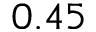<formula> <loc_0><loc_0><loc_500><loc_500>0 . 4 5</formula> 